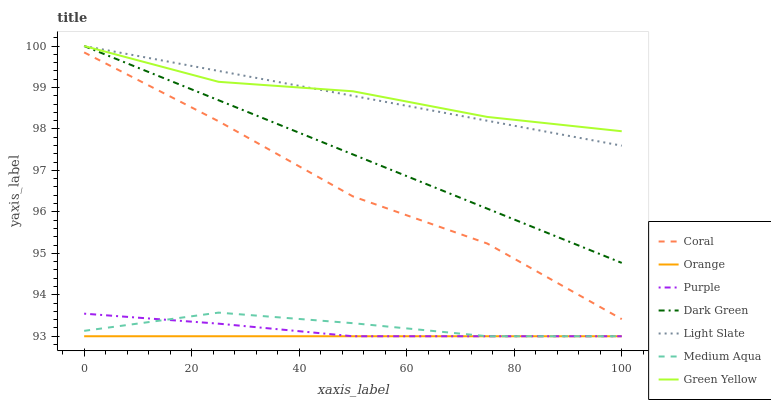Does Orange have the minimum area under the curve?
Answer yes or no. Yes. Does Green Yellow have the maximum area under the curve?
Answer yes or no. Yes. Does Coral have the minimum area under the curve?
Answer yes or no. No. Does Coral have the maximum area under the curve?
Answer yes or no. No. Is Orange the smoothest?
Answer yes or no. Yes. Is Coral the roughest?
Answer yes or no. Yes. Is Light Slate the smoothest?
Answer yes or no. No. Is Light Slate the roughest?
Answer yes or no. No. Does Purple have the lowest value?
Answer yes or no. Yes. Does Coral have the lowest value?
Answer yes or no. No. Does Dark Green have the highest value?
Answer yes or no. Yes. Does Coral have the highest value?
Answer yes or no. No. Is Medium Aqua less than Dark Green?
Answer yes or no. Yes. Is Green Yellow greater than Orange?
Answer yes or no. Yes. Does Orange intersect Purple?
Answer yes or no. Yes. Is Orange less than Purple?
Answer yes or no. No. Is Orange greater than Purple?
Answer yes or no. No. Does Medium Aqua intersect Dark Green?
Answer yes or no. No. 